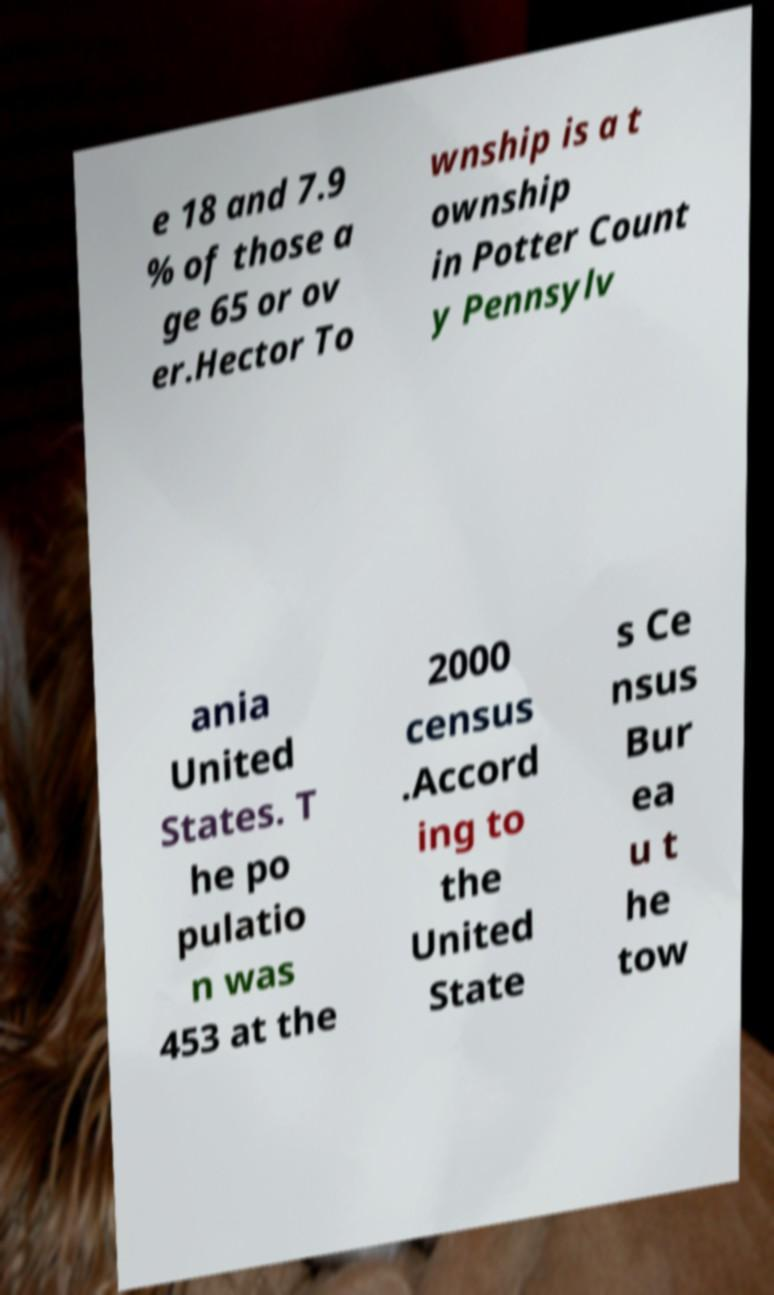Can you accurately transcribe the text from the provided image for me? e 18 and 7.9 % of those a ge 65 or ov er.Hector To wnship is a t ownship in Potter Count y Pennsylv ania United States. T he po pulatio n was 453 at the 2000 census .Accord ing to the United State s Ce nsus Bur ea u t he tow 